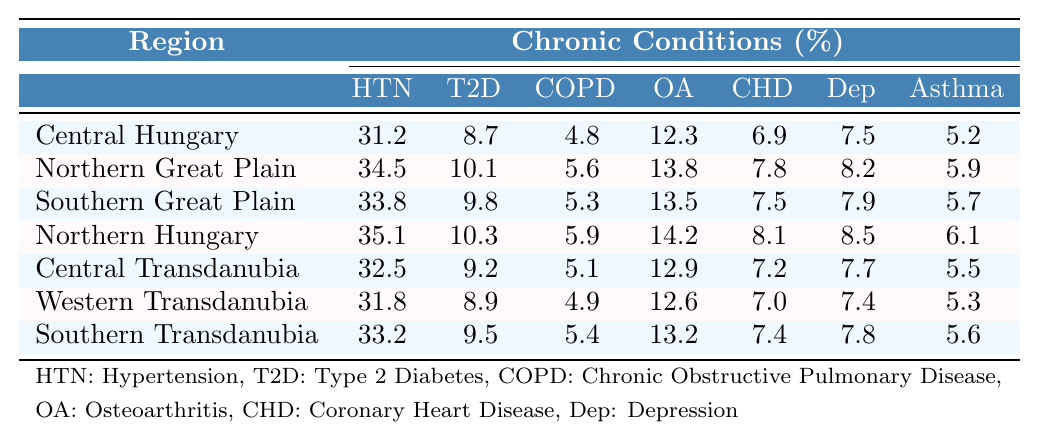What is the prevalence of Hypertension in Northern Hungary? According to the table, the prevalence of Hypertension in Northern Hungary is listed as 35.1%.
Answer: 35.1% Which region has the highest prevalence of Type 2 Diabetes? By comparing the values for Type 2 Diabetes across regions, Northern Hungary has the highest prevalence at 10.3%.
Answer: Northern Hungary What is the prevalence of Chronic Obstructive Pulmonary Disease (COPD) in Southern Great Plain? The table shows that the prevalence of COPD in Southern Great Plain is 5.3%.
Answer: 5.3% Which condition has the lowest prevalence in Central Hungary? Looking at the prevalence data for Central Hungary, the lowest percentage is 4.8% for COPD.
Answer: COPD What is the average prevalence of Osteoarthritis across all regions? Adding the values for Osteoarthritis (12.3 + 13.8 + 13.5 + 14.2 + 12.9 + 12.6 + 13.2) totals 88.5, and dividing by 7 regions gives an average of approximately 12.6%.
Answer: 12.6% Is the prevalence of Depression higher in Central Transdanubia than in Western Transdanubia? Comparing the two regions, Central Transdanubia has a prevalence of 7.7% while Western Transdanubia has 7.4%. Therefore, it is true that Central Transdanubia has a higher prevalence.
Answer: Yes How much higher is the prevalence of Coronary Heart Disease in Northern Hungary compared to Central Hungary? The prevalence of Coronary Heart Disease in Northern Hungary is 8.1% and in Central Hungary is 6.9%. The difference is 8.1 - 6.9 = 1.2%.
Answer: 1.2% What percentage of the population in the Northern Great Plain suffers from Asthma? The table specifies that the prevalence of Asthma in the Northern Great Plain is 5.9%.
Answer: 5.9% Which region has the highest overall prevalence of chronic conditions when looking at all conditions combined? To find this, we must sum the prevalence percentages for all conditions in each region. Northern Hungary has the highest combined total (35.1 + 10.3 + 5.9 + 14.2 + 8.1 + 8.5 + 6.1 = 88.2%).
Answer: Northern Hungary Is there any region where the prevalence of Hypertension is less than 30%? By examining the table, all listed regions have a prevalence of Hypertension over 30%, so the answer is no, there is no region with less than 30%.
Answer: No 